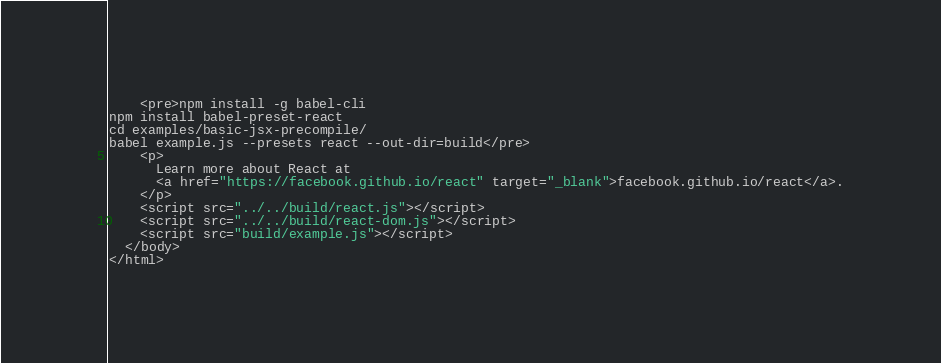<code> <loc_0><loc_0><loc_500><loc_500><_HTML_>    <pre>npm install -g babel-cli
npm install babel-preset-react
cd examples/basic-jsx-precompile/
babel example.js --presets react --out-dir=build</pre>
    <p>
      Learn more about React at
      <a href="https://facebook.github.io/react" target="_blank">facebook.github.io/react</a>.
    </p>
    <script src="../../build/react.js"></script>
    <script src="../../build/react-dom.js"></script>
    <script src="build/example.js"></script>
  </body>
</html>
</code> 